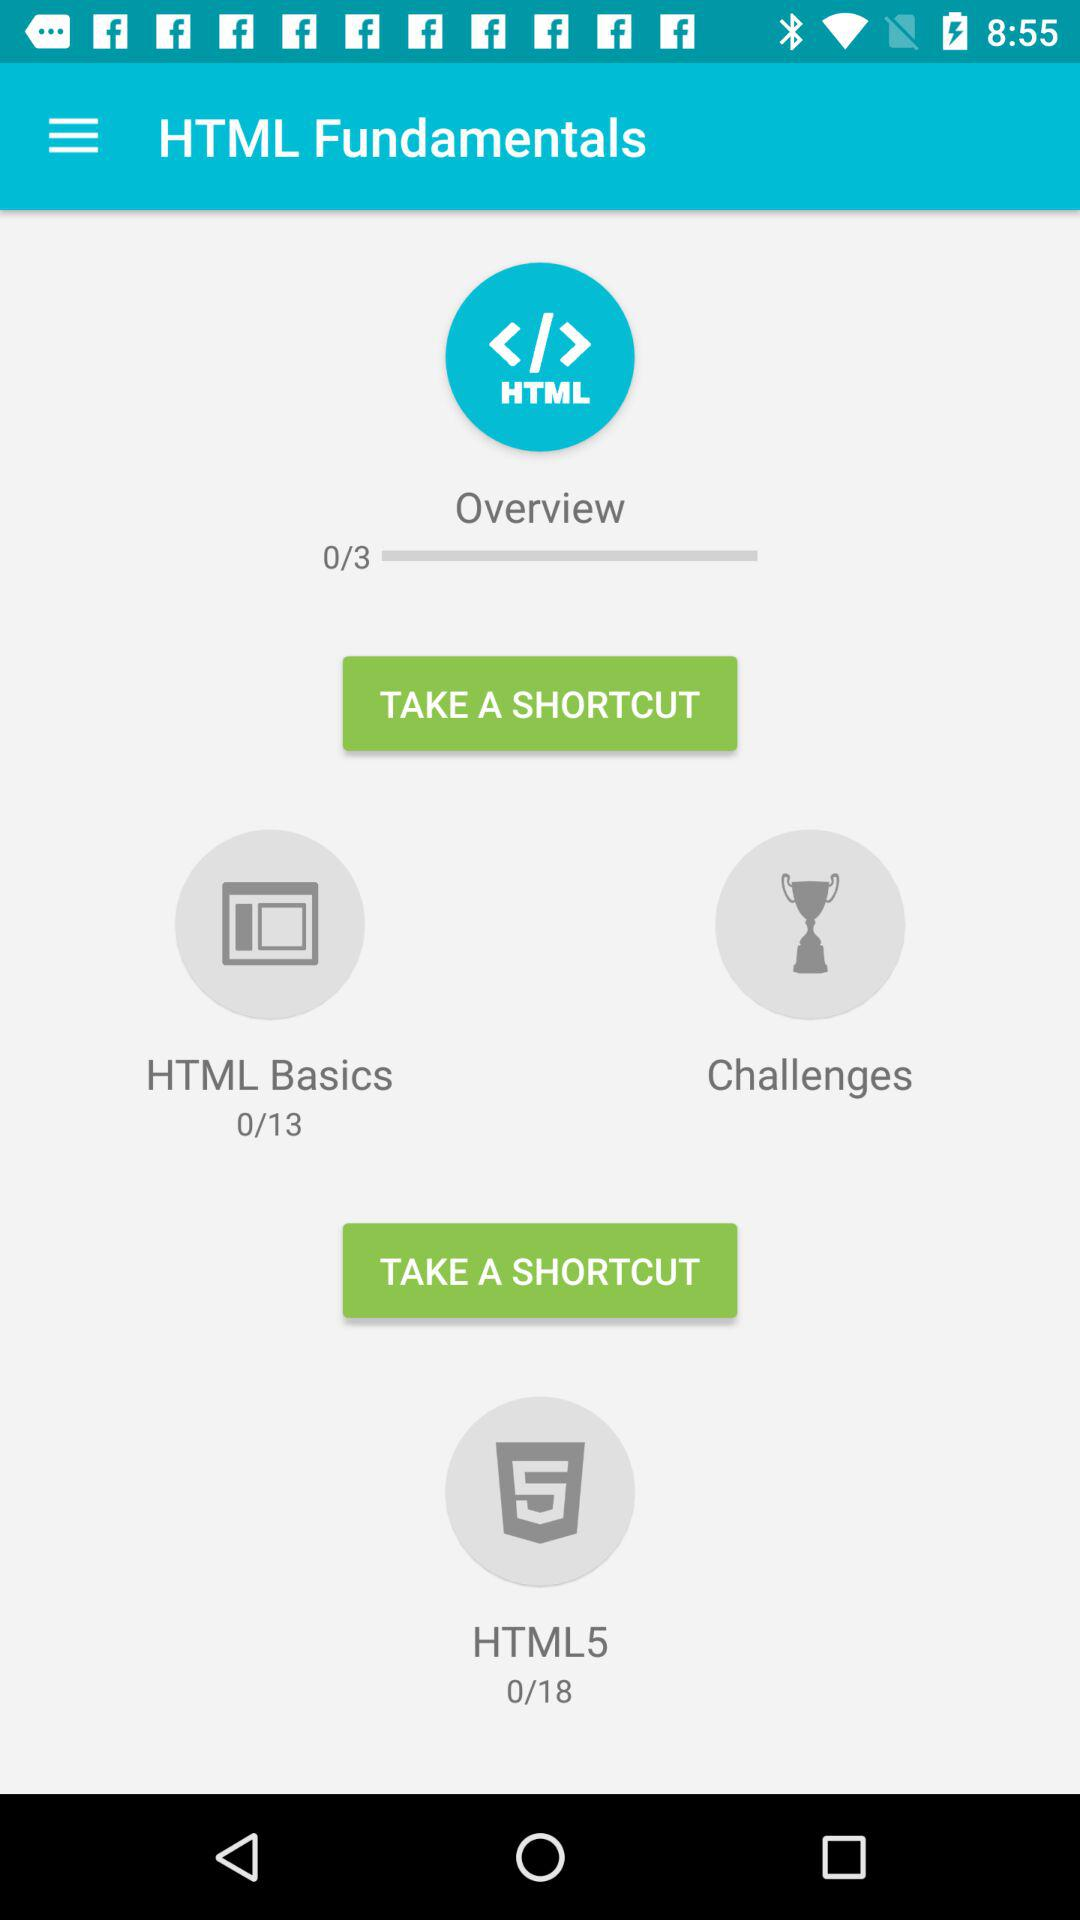How many lessons are there in "HTML Basics"? There are 13 lessons in "HTML Basics". 